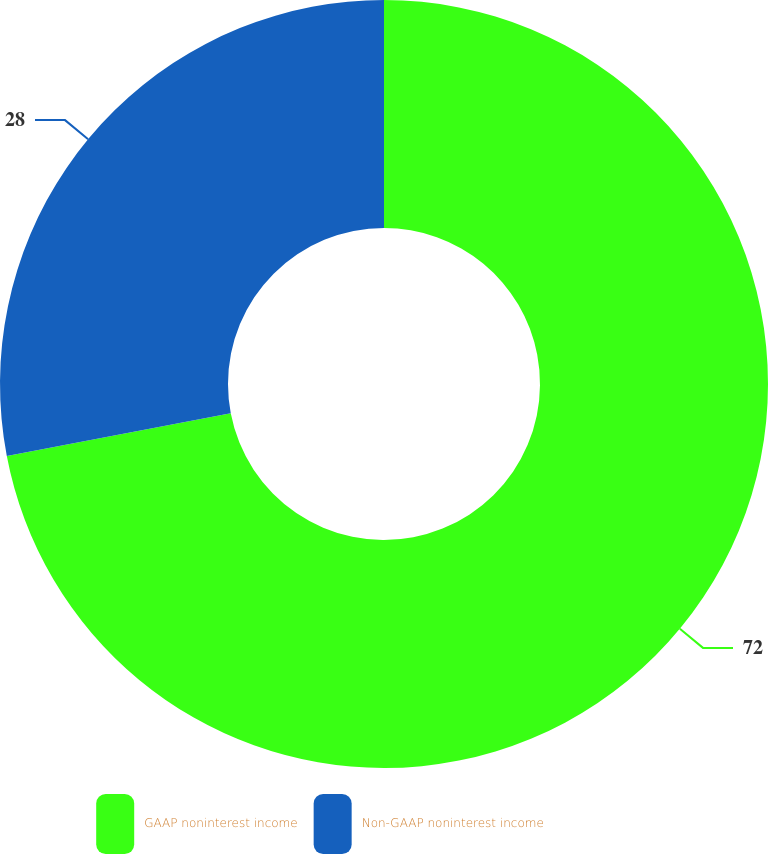Convert chart to OTSL. <chart><loc_0><loc_0><loc_500><loc_500><pie_chart><fcel>GAAP noninterest income<fcel>Non-GAAP noninterest income<nl><fcel>72.0%<fcel>28.0%<nl></chart> 